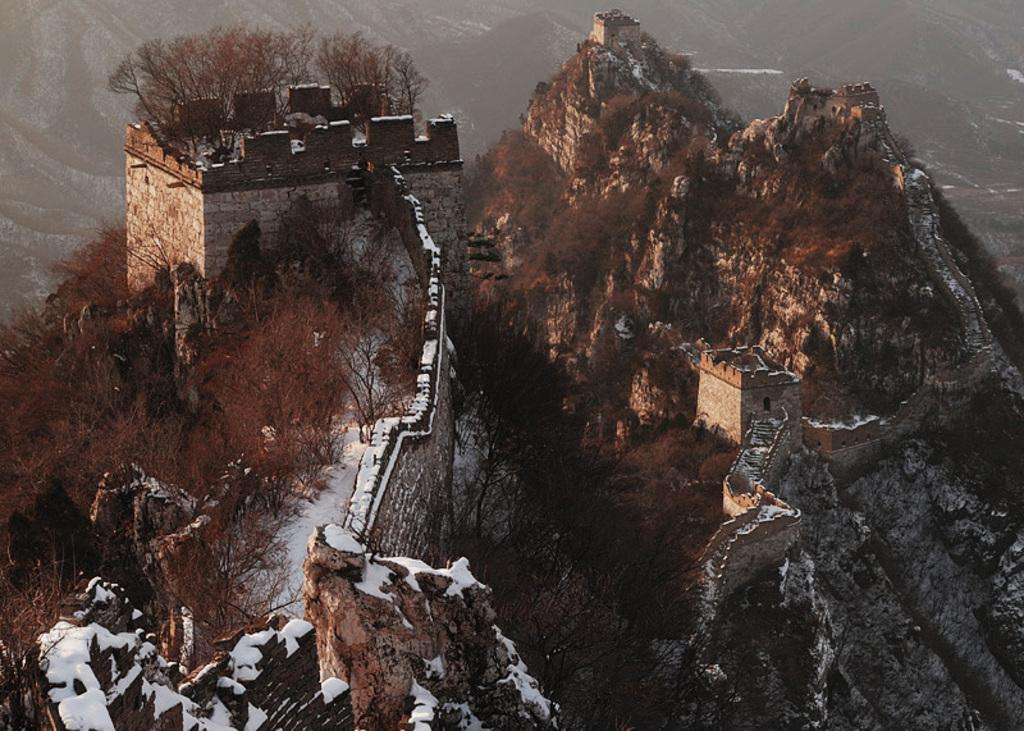What type of landscape is depicted in the image? The image shows buildings on mountains. What other natural elements can be seen in the image? There is a group of trees in the image. What is the weather like in the image? There is snow visible in the image, indicating a cold or snowy environment. Where is the dock located in the image? There is no dock present in the image. What action is the tin performing in the image? There is no tin present in the image, and therefore no action can be attributed to it. 